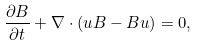Convert formula to latex. <formula><loc_0><loc_0><loc_500><loc_500>\frac { \partial B } { \partial t } + \nabla \cdot ( { u B } - { B u } ) = 0 ,</formula> 